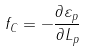Convert formula to latex. <formula><loc_0><loc_0><loc_500><loc_500>f _ { C } = - \frac { \partial \varepsilon _ { p } } { \partial L _ { p } }</formula> 